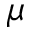Convert formula to latex. <formula><loc_0><loc_0><loc_500><loc_500>\mu</formula> 